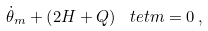<formula> <loc_0><loc_0><loc_500><loc_500>\dot { \theta } _ { m } + \left ( 2 H + Q \right ) \ t e t m = 0 \, ,</formula> 